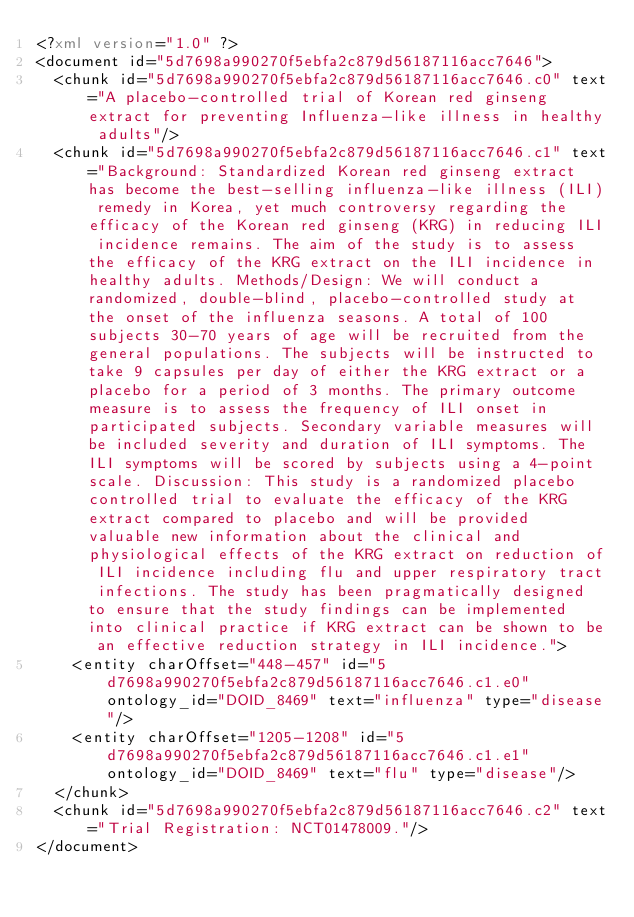<code> <loc_0><loc_0><loc_500><loc_500><_XML_><?xml version="1.0" ?>
<document id="5d7698a990270f5ebfa2c879d56187116acc7646">
  <chunk id="5d7698a990270f5ebfa2c879d56187116acc7646.c0" text="A placebo-controlled trial of Korean red ginseng extract for preventing Influenza-like illness in healthy adults"/>
  <chunk id="5d7698a990270f5ebfa2c879d56187116acc7646.c1" text="Background: Standardized Korean red ginseng extract has become the best-selling influenza-like illness (ILI) remedy in Korea, yet much controversy regarding the efficacy of the Korean red ginseng (KRG) in reducing ILI incidence remains. The aim of the study is to assess the efficacy of the KRG extract on the ILI incidence in healthy adults. Methods/Design: We will conduct a randomized, double-blind, placebo-controlled study at the onset of the influenza seasons. A total of 100 subjects 30-70 years of age will be recruited from the general populations. The subjects will be instructed to take 9 capsules per day of either the KRG extract or a placebo for a period of 3 months. The primary outcome measure is to assess the frequency of ILI onset in participated subjects. Secondary variable measures will be included severity and duration of ILI symptoms. The ILI symptoms will be scored by subjects using a 4-point scale. Discussion: This study is a randomized placebo controlled trial to evaluate the efficacy of the KRG extract compared to placebo and will be provided valuable new information about the clinical and physiological effects of the KRG extract on reduction of ILI incidence including flu and upper respiratory tract infections. The study has been pragmatically designed to ensure that the study findings can be implemented into clinical practice if KRG extract can be shown to be an effective reduction strategy in ILI incidence.">
    <entity charOffset="448-457" id="5d7698a990270f5ebfa2c879d56187116acc7646.c1.e0" ontology_id="DOID_8469" text="influenza" type="disease"/>
    <entity charOffset="1205-1208" id="5d7698a990270f5ebfa2c879d56187116acc7646.c1.e1" ontology_id="DOID_8469" text="flu" type="disease"/>
  </chunk>
  <chunk id="5d7698a990270f5ebfa2c879d56187116acc7646.c2" text="Trial Registration: NCT01478009."/>
</document>
</code> 